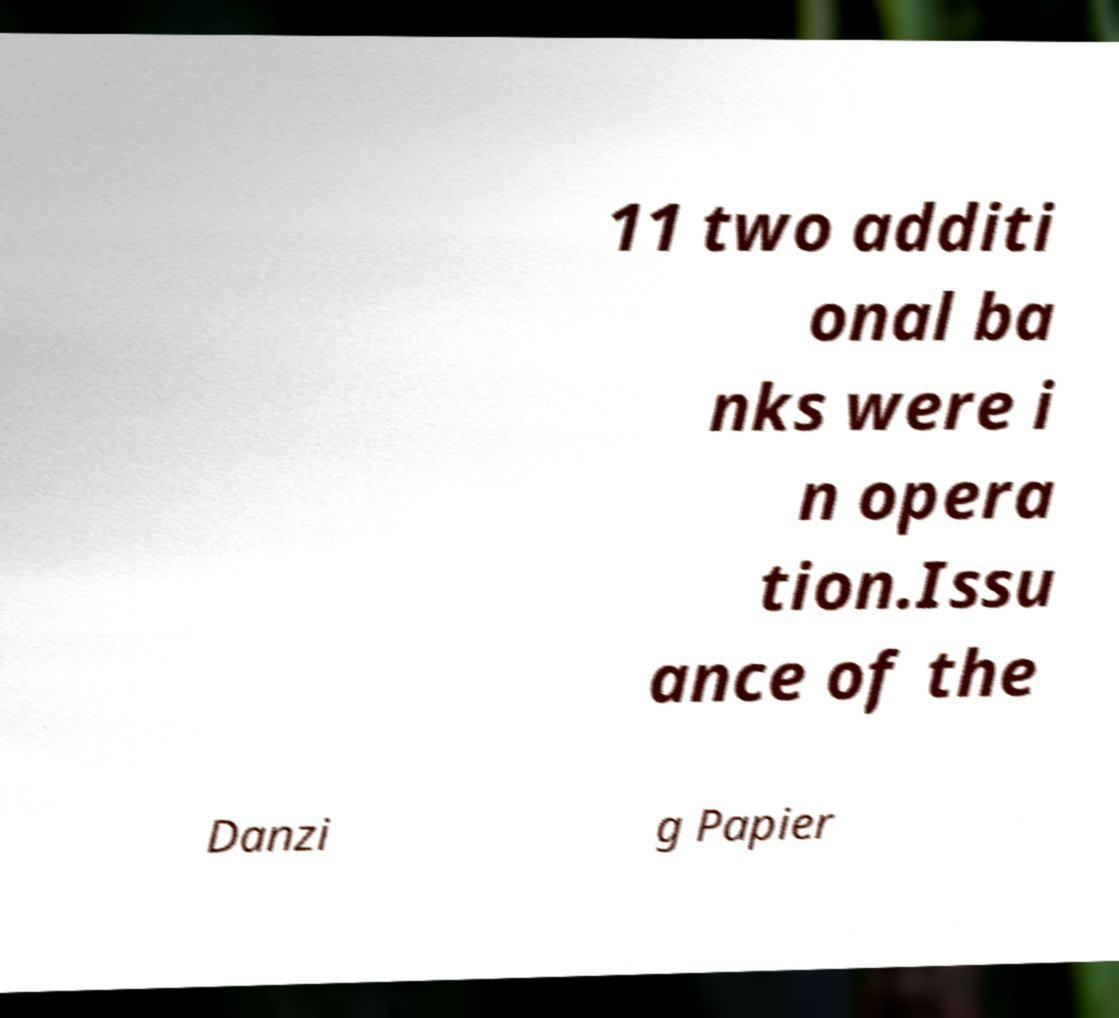Please identify and transcribe the text found in this image. 11 two additi onal ba nks were i n opera tion.Issu ance of the Danzi g Papier 